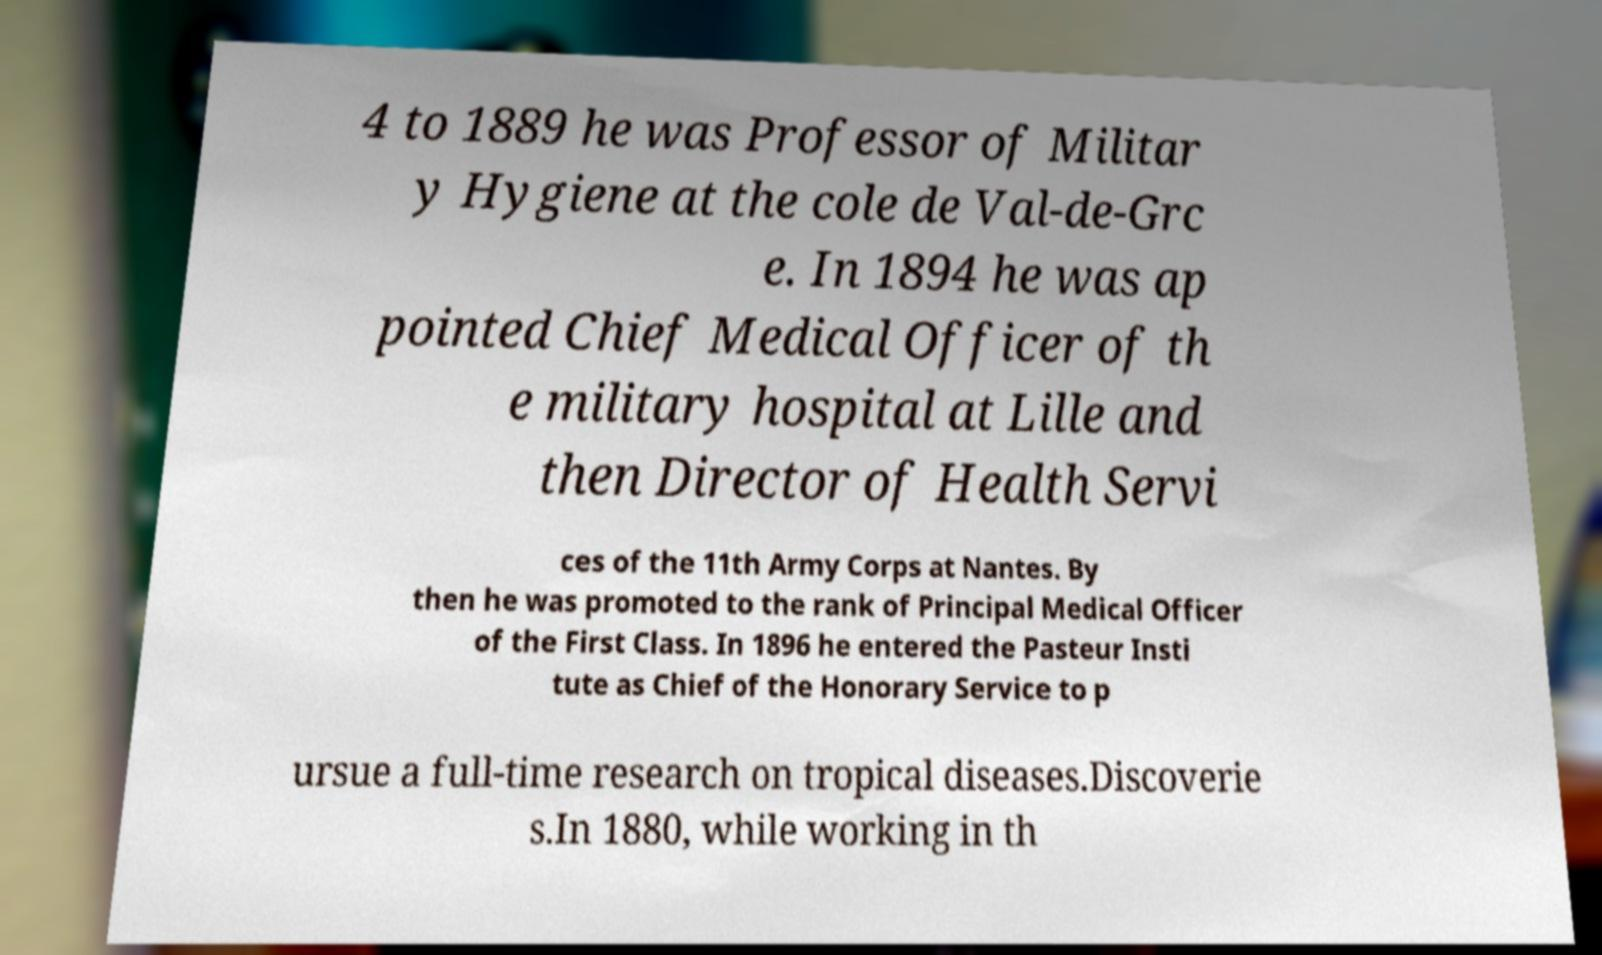Please read and relay the text visible in this image. What does it say? 4 to 1889 he was Professor of Militar y Hygiene at the cole de Val-de-Grc e. In 1894 he was ap pointed Chief Medical Officer of th e military hospital at Lille and then Director of Health Servi ces of the 11th Army Corps at Nantes. By then he was promoted to the rank of Principal Medical Officer of the First Class. In 1896 he entered the Pasteur Insti tute as Chief of the Honorary Service to p ursue a full-time research on tropical diseases.Discoverie s.In 1880, while working in th 